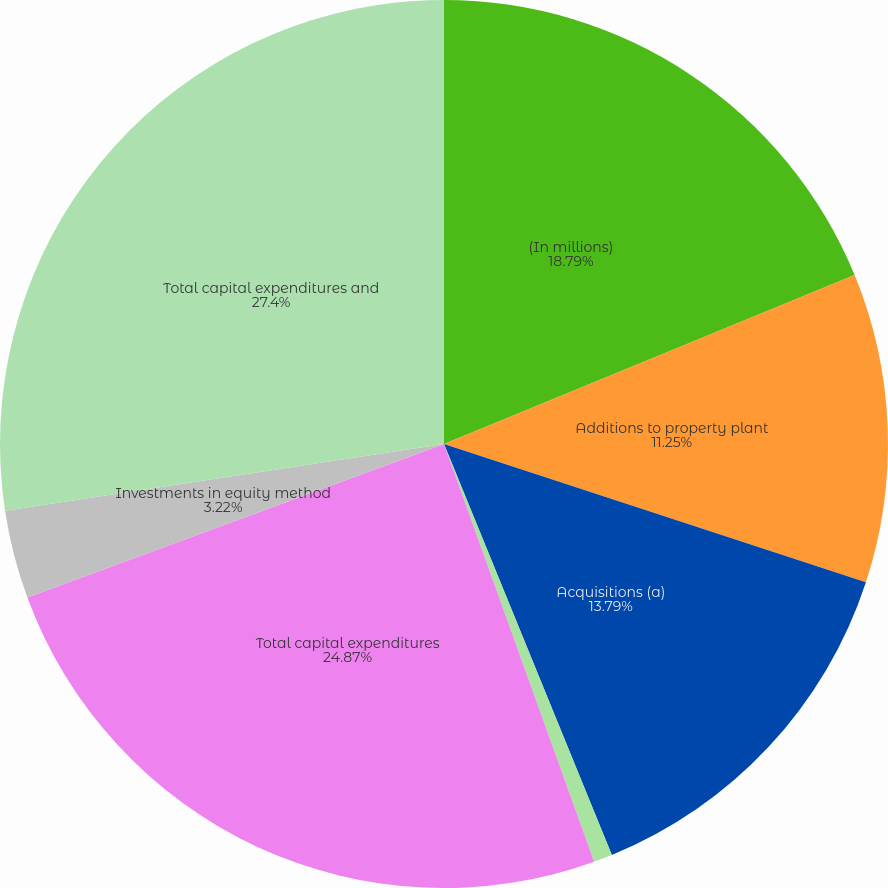Convert chart. <chart><loc_0><loc_0><loc_500><loc_500><pie_chart><fcel>(In millions)<fcel>Additions to property plant<fcel>Acquisitions (a)<fcel>Increase (decrease) in capital<fcel>Total capital expenditures<fcel>Investments in equity method<fcel>Total capital expenditures and<nl><fcel>18.79%<fcel>11.25%<fcel>13.79%<fcel>0.68%<fcel>24.87%<fcel>3.22%<fcel>27.4%<nl></chart> 